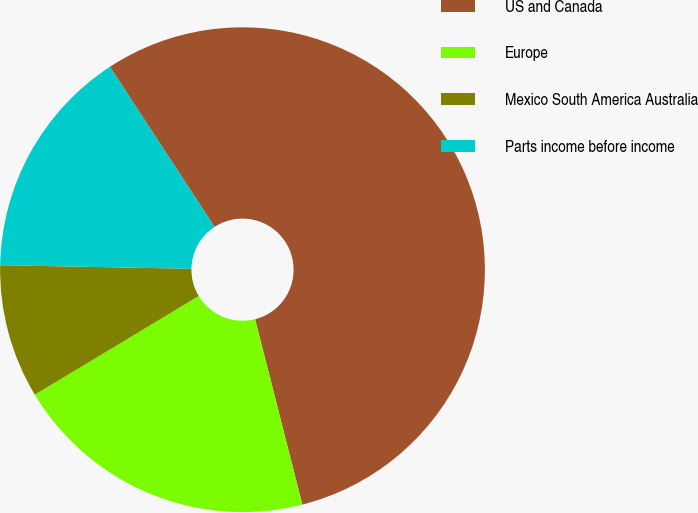Convert chart to OTSL. <chart><loc_0><loc_0><loc_500><loc_500><pie_chart><fcel>US and Canada<fcel>Europe<fcel>Mexico South America Australia<fcel>Parts income before income<nl><fcel>55.25%<fcel>20.35%<fcel>8.92%<fcel>15.49%<nl></chart> 